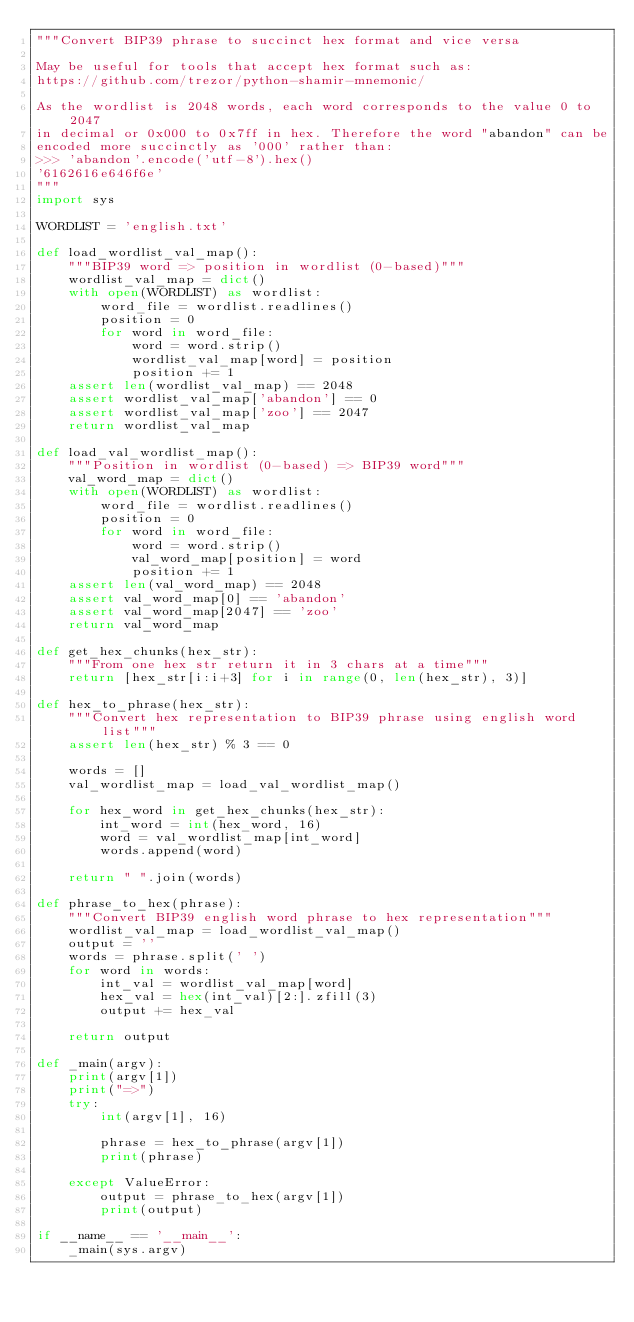<code> <loc_0><loc_0><loc_500><loc_500><_Python_>"""Convert BIP39 phrase to succinct hex format and vice versa

May be useful for tools that accept hex format such as:
https://github.com/trezor/python-shamir-mnemonic/

As the wordlist is 2048 words, each word corresponds to the value 0 to 2047
in decimal or 0x000 to 0x7ff in hex. Therefore the word "abandon" can be
encoded more succinctly as '000' rather than:
>>> 'abandon'.encode('utf-8').hex()
'6162616e646f6e'
"""
import sys

WORDLIST = 'english.txt'

def load_wordlist_val_map():
    """BIP39 word => position in wordlist (0-based)"""
    wordlist_val_map = dict()
    with open(WORDLIST) as wordlist:
        word_file = wordlist.readlines()
        position = 0
        for word in word_file:
            word = word.strip()
            wordlist_val_map[word] = position
            position += 1
    assert len(wordlist_val_map) == 2048
    assert wordlist_val_map['abandon'] == 0
    assert wordlist_val_map['zoo'] == 2047
    return wordlist_val_map

def load_val_wordlist_map():
    """Position in wordlist (0-based) => BIP39 word"""
    val_word_map = dict()
    with open(WORDLIST) as wordlist:
        word_file = wordlist.readlines()
        position = 0
        for word in word_file:
            word = word.strip()
            val_word_map[position] = word
            position += 1
    assert len(val_word_map) == 2048
    assert val_word_map[0] == 'abandon'
    assert val_word_map[2047] == 'zoo'
    return val_word_map

def get_hex_chunks(hex_str):
    """From one hex str return it in 3 chars at a time"""
    return [hex_str[i:i+3] for i in range(0, len(hex_str), 3)]

def hex_to_phrase(hex_str):
    """Convert hex representation to BIP39 phrase using english word list"""
    assert len(hex_str) % 3 == 0

    words = []
    val_wordlist_map = load_val_wordlist_map()

    for hex_word in get_hex_chunks(hex_str):
        int_word = int(hex_word, 16)
        word = val_wordlist_map[int_word]
        words.append(word)

    return " ".join(words)

def phrase_to_hex(phrase):
    """Convert BIP39 english word phrase to hex representation"""
    wordlist_val_map = load_wordlist_val_map()
    output = ''
    words = phrase.split(' ')
    for word in words:
        int_val = wordlist_val_map[word]
        hex_val = hex(int_val)[2:].zfill(3)
        output += hex_val

    return output

def _main(argv):
    print(argv[1])
    print("=>")
    try:
        int(argv[1], 16)

        phrase = hex_to_phrase(argv[1])
        print(phrase)

    except ValueError:
        output = phrase_to_hex(argv[1])
        print(output)

if __name__ == '__main__':
    _main(sys.argv)
</code> 